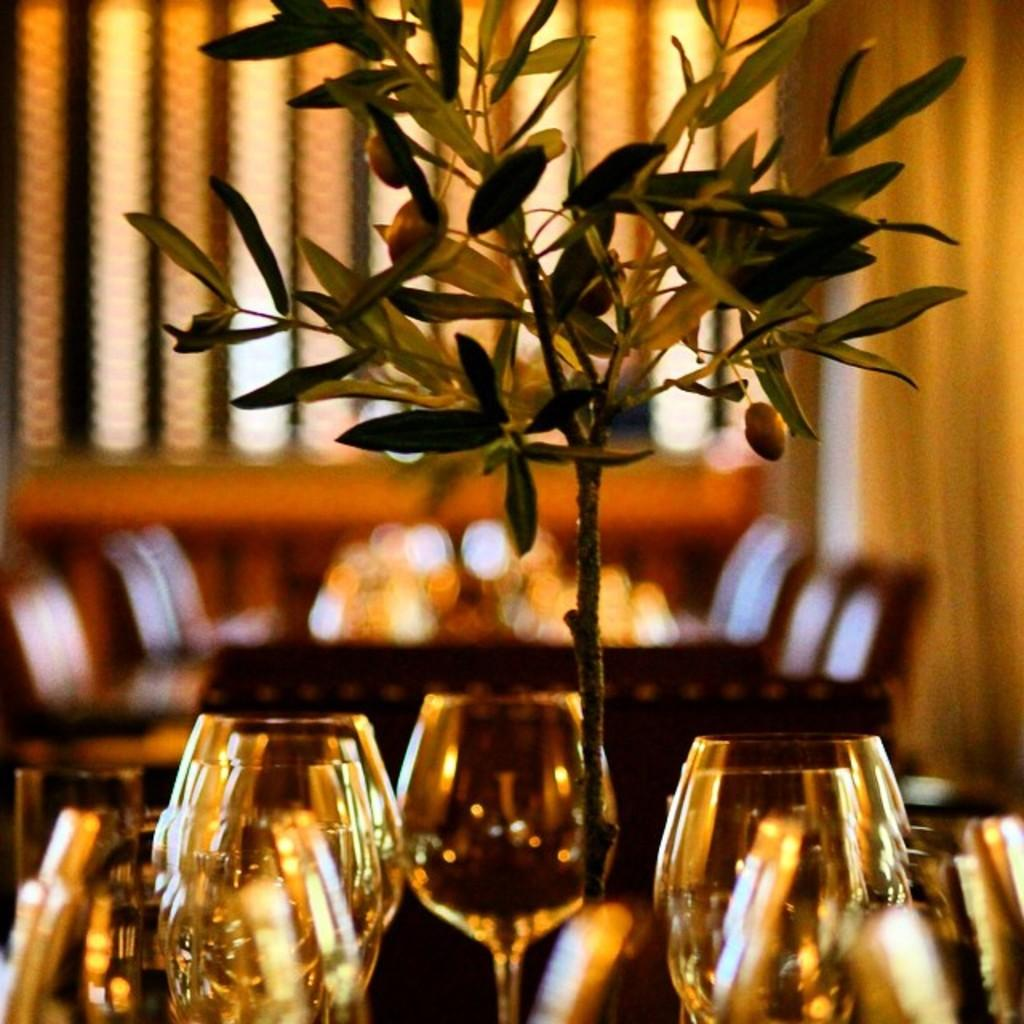What type of living organism is present in the image? There is a plant in the image. What objects are present in the image that might be used for drinking? There are glasses in the image. What type of furniture is present in the image? There are chairs in the image. What type of surface is present in the image that might be used for placing objects? There is a table in the image. What type of ship can be seen sailing in the image? There is no ship present in the image. What type of authority figure can be seen in the image? There is no authority figure present in the image. What time of day is depicted in the image? The time of day is not depicted in the image. 